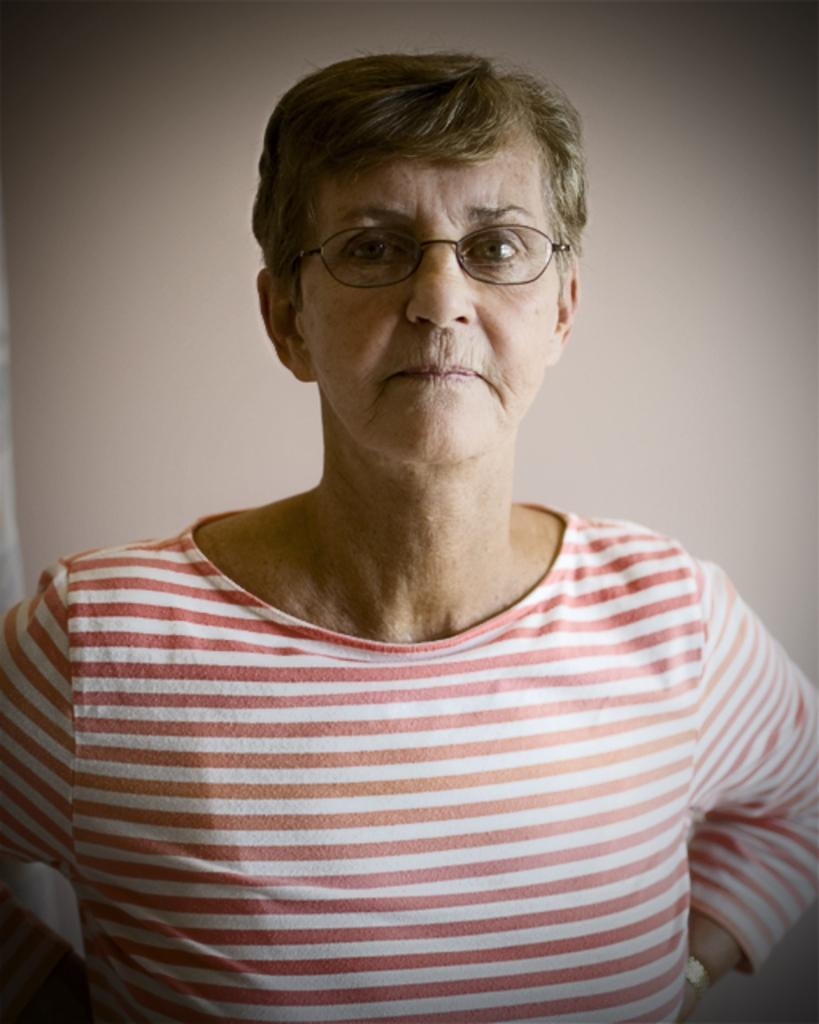Who is the main subject in the image? There is a lady in the center of the image. What is the lady doing in the image? The lady is standing. What is the lady wearing on her upper body? The lady is wearing a t-shirt. What accessories is the lady wearing in the image? The lady is wearing spectacles and a watch. What can be seen in the background of the image? There is a wall in the background of the image. Can you see any police officers or feathers in the image? No, there are no police officers or feathers present in the image. Is the lady wearing a boot in the image? No, the lady is not wearing a boot in the image; she is wearing a watch. 